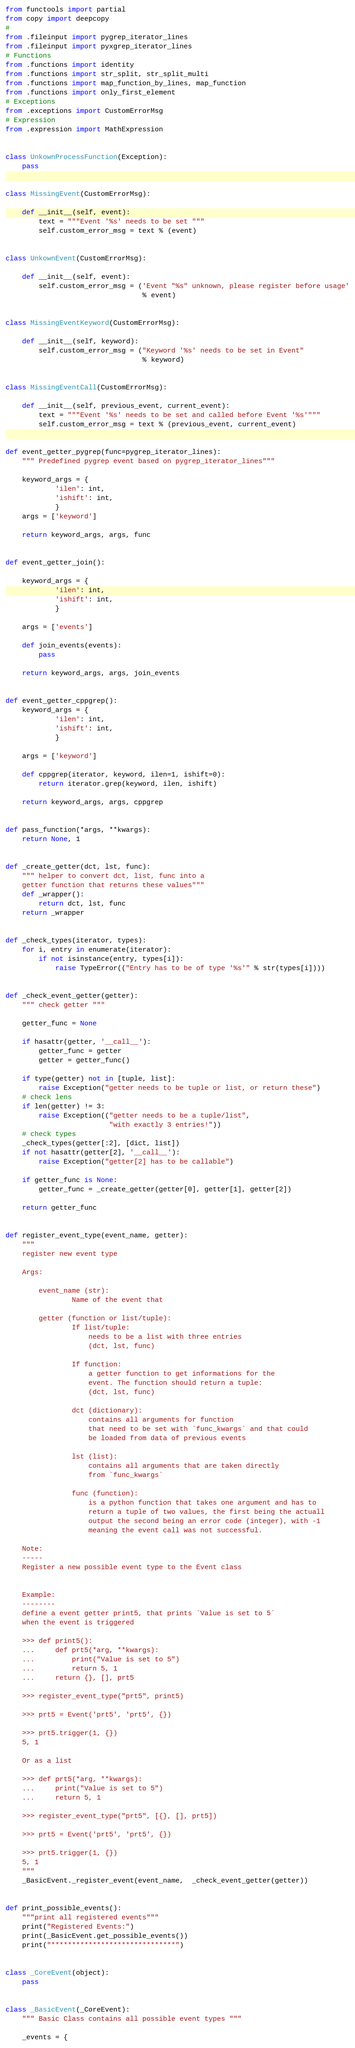<code> <loc_0><loc_0><loc_500><loc_500><_Python_>from functools import partial
from copy import deepcopy
#
from .fileinput import pygrep_iterator_lines
from .fileinput import pyxgrep_iterator_lines
# Functions
from .functions import identity
from .functions import str_split, str_split_multi
from .functions import map_function_by_lines, map_function
from .functions import only_first_element
# Exceptions
from .exceptions import CustomErrorMsg
# Expression
from .expression import MathExpression


class UnkownProcessFunction(Exception):
    pass


class MissingEvent(CustomErrorMsg):

    def __init__(self, event):
        text = """Event '%s' needs to be set """
        self.custom_error_msg = text % (event)


class UnkownEvent(CustomErrorMsg):

    def __init__(self, event):
        self.custom_error_msg = ('Event "%s" unknown, please register before usage'
                                 % event)


class MissingEventKeyword(CustomErrorMsg):

    def __init__(self, keyword):
        self.custom_error_msg = ("Keyword '%s' needs to be set in Event"
                                 % keyword)


class MissingEventCall(CustomErrorMsg):

    def __init__(self, previous_event, current_event):
        text = """Event '%s' needs to be set and called before Event '%s'"""
        self.custom_error_msg = text % (previous_event, current_event)


def event_getter_pygrep(func=pygrep_iterator_lines):
    """ Predefined pygrep event based on pygrep_iterator_lines"""

    keyword_args = {
            'ilen': int,
            'ishift': int,
            }
    args = ['keyword']

    return keyword_args, args, func


def event_getter_join():

    keyword_args = {
            'ilen': int,
            'ishift': int,
            }

    args = ['events']

    def join_events(events):
        pass

    return keyword_args, args, join_events


def event_getter_cppgrep():
    keyword_args = {
            'ilen': int,
            'ishift': int,
            }

    args = ['keyword']

    def cppgrep(iterator, keyword, ilen=1, ishift=0):
        return iterator.grep(keyword, ilen, ishift)

    return keyword_args, args, cppgrep


def pass_function(*args, **kwargs):
    return None, 1


def _create_getter(dct, lst, func):
    """ helper to convert dct, list, func into a
    getter function that returns these values"""
    def _wrapper():
        return dct, lst, func
    return _wrapper


def _check_types(iterator, types):
    for i, entry in enumerate(iterator):
        if not isinstance(entry, types[i]):
            raise TypeError(("Entry has to be of type '%s'" % str(types[i])))


def _check_event_getter(getter):
    """ check getter """

    getter_func = None

    if hasattr(getter, '__call__'):
        getter_func = getter
        getter = getter_func()

    if type(getter) not in [tuple, list]:
        raise Exception("getter needs to be tuple or list, or return these")
    # check lens
    if len(getter) != 3:
        raise Exception(("getter needs to be a tuple/list",
                         "with exactly 3 entries!"))
    # check types
    _check_types(getter[:2], [dict, list])
    if not hasattr(getter[2], '__call__'):
        raise Exception("getter[2] has to be callable")

    if getter_func is None:
        getter_func = _create_getter(getter[0], getter[1], getter[2])

    return getter_func


def register_event_type(event_name, getter):
    """
    register new event type

    Args:

        event_name (str):
                Name of the event that

        getter (function or list/tuple):
                If list/tuple:
                    needs to be a list with three entries
                    (dct, lst, func)

                If function:
                    a getter function to get informations for the
                    event. The function should return a tuple:
                    (dct, lst, func)

                dct (dictionary):
                    contains all arguments for function
                    that need to be set with `func_kwargs` and that could
                    be loaded from data of previous events

                lst (list):
                    contains all arguments that are taken directly
                    from `func_kwargs`

                func (function):
                    is a python function that takes one argument and has to
                    return a tuple of two values, the first being the actuall
                    output the second being an error code (integer), with -1
                    meaning the event call was not successful.

    Note:
    -----
    Register a new possible event type to the Event class


    Example:
    --------
    define a event getter print5, that prints `Value is set to 5`
    when the event is triggered

    >>> def print5():
    ...     def prt5(*arg, **kwargs):
    ...         print("Value is set to 5")
    ...         return 5, 1
    ...     return {}, [], prt5

    >>> register_event_type("prt5", print5)

    >>> prt5 = Event('prt5', 'prt5', {})

    >>> prt5.trigger(1, {})
    5, 1

    Or as a list

    >>> def prt5(*arg, **kwargs):
    ...     print("Value is set to 5")
    ...     return 5, 1

    >>> register_event_type("prt5", [{}, [], prt5])

    >>> prt5 = Event('prt5', 'prt5', {})

    >>> prt5.trigger(1, {})
    5, 1
    """
    _BasicEvent._register_event(event_name,  _check_event_getter(getter))


def print_possible_events():
    """print all registered events"""
    print("Registered Events:")
    print(_BasicEvent.get_possible_events())
    print("******************************")


class _CoreEvent(object):
    pass


class _BasicEvent(_CoreEvent):
    """ Basic Class contains all possible event types """

    _events = {</code> 